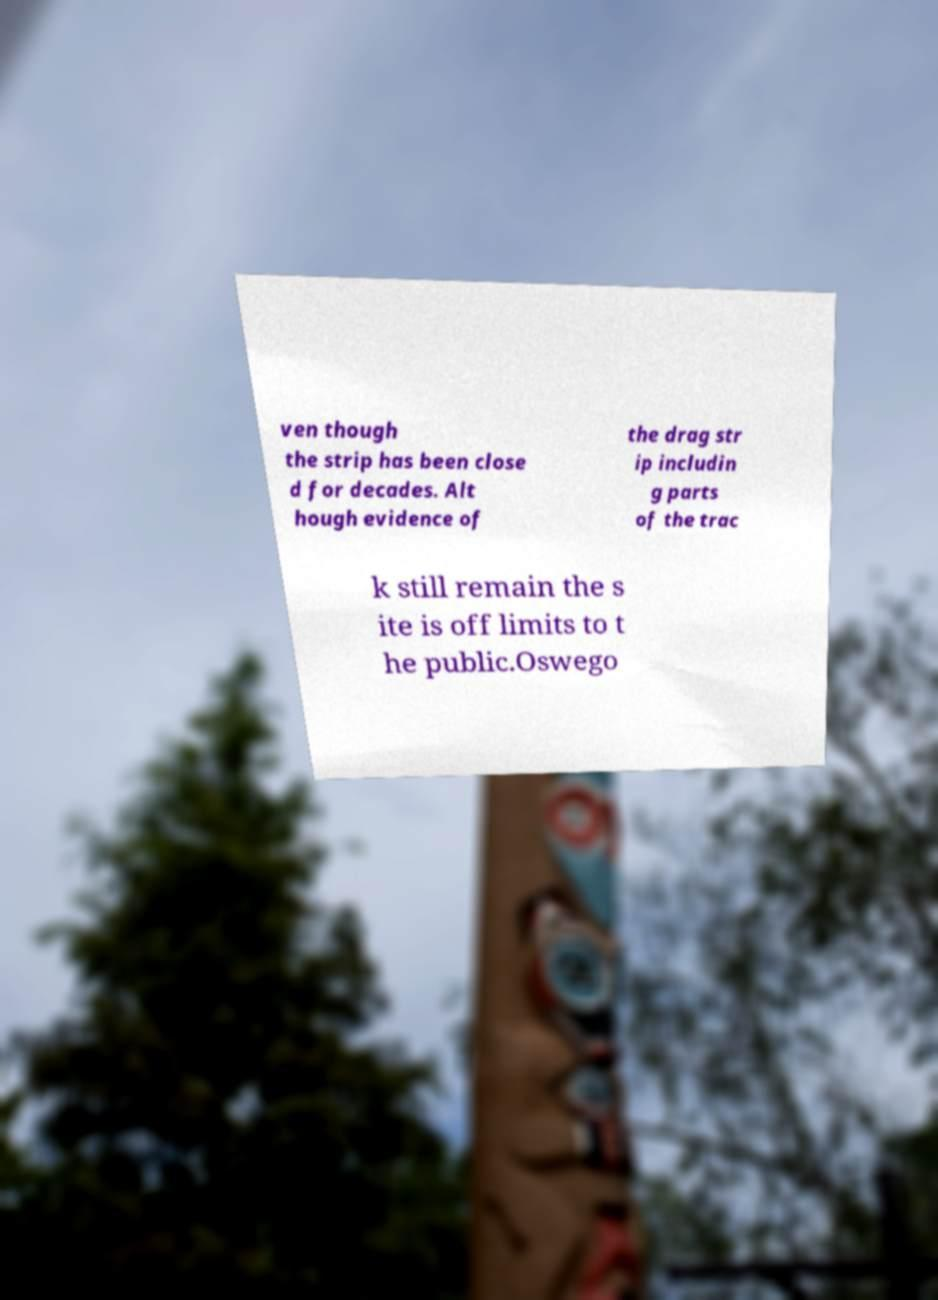There's text embedded in this image that I need extracted. Can you transcribe it verbatim? ven though the strip has been close d for decades. Alt hough evidence of the drag str ip includin g parts of the trac k still remain the s ite is off limits to t he public.Oswego 